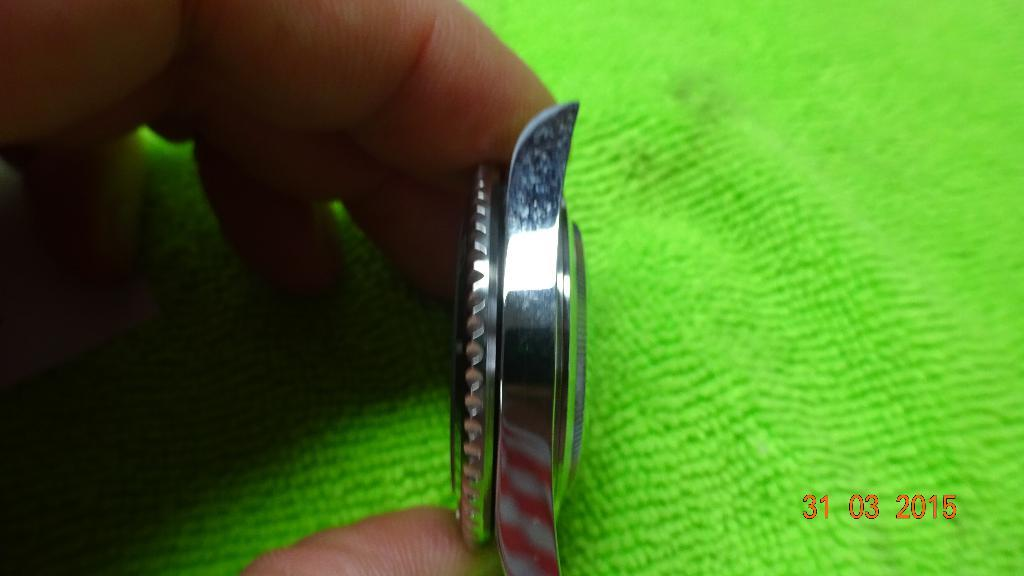<image>
Present a compact description of the photo's key features. an item with the date of 03 31 on it 